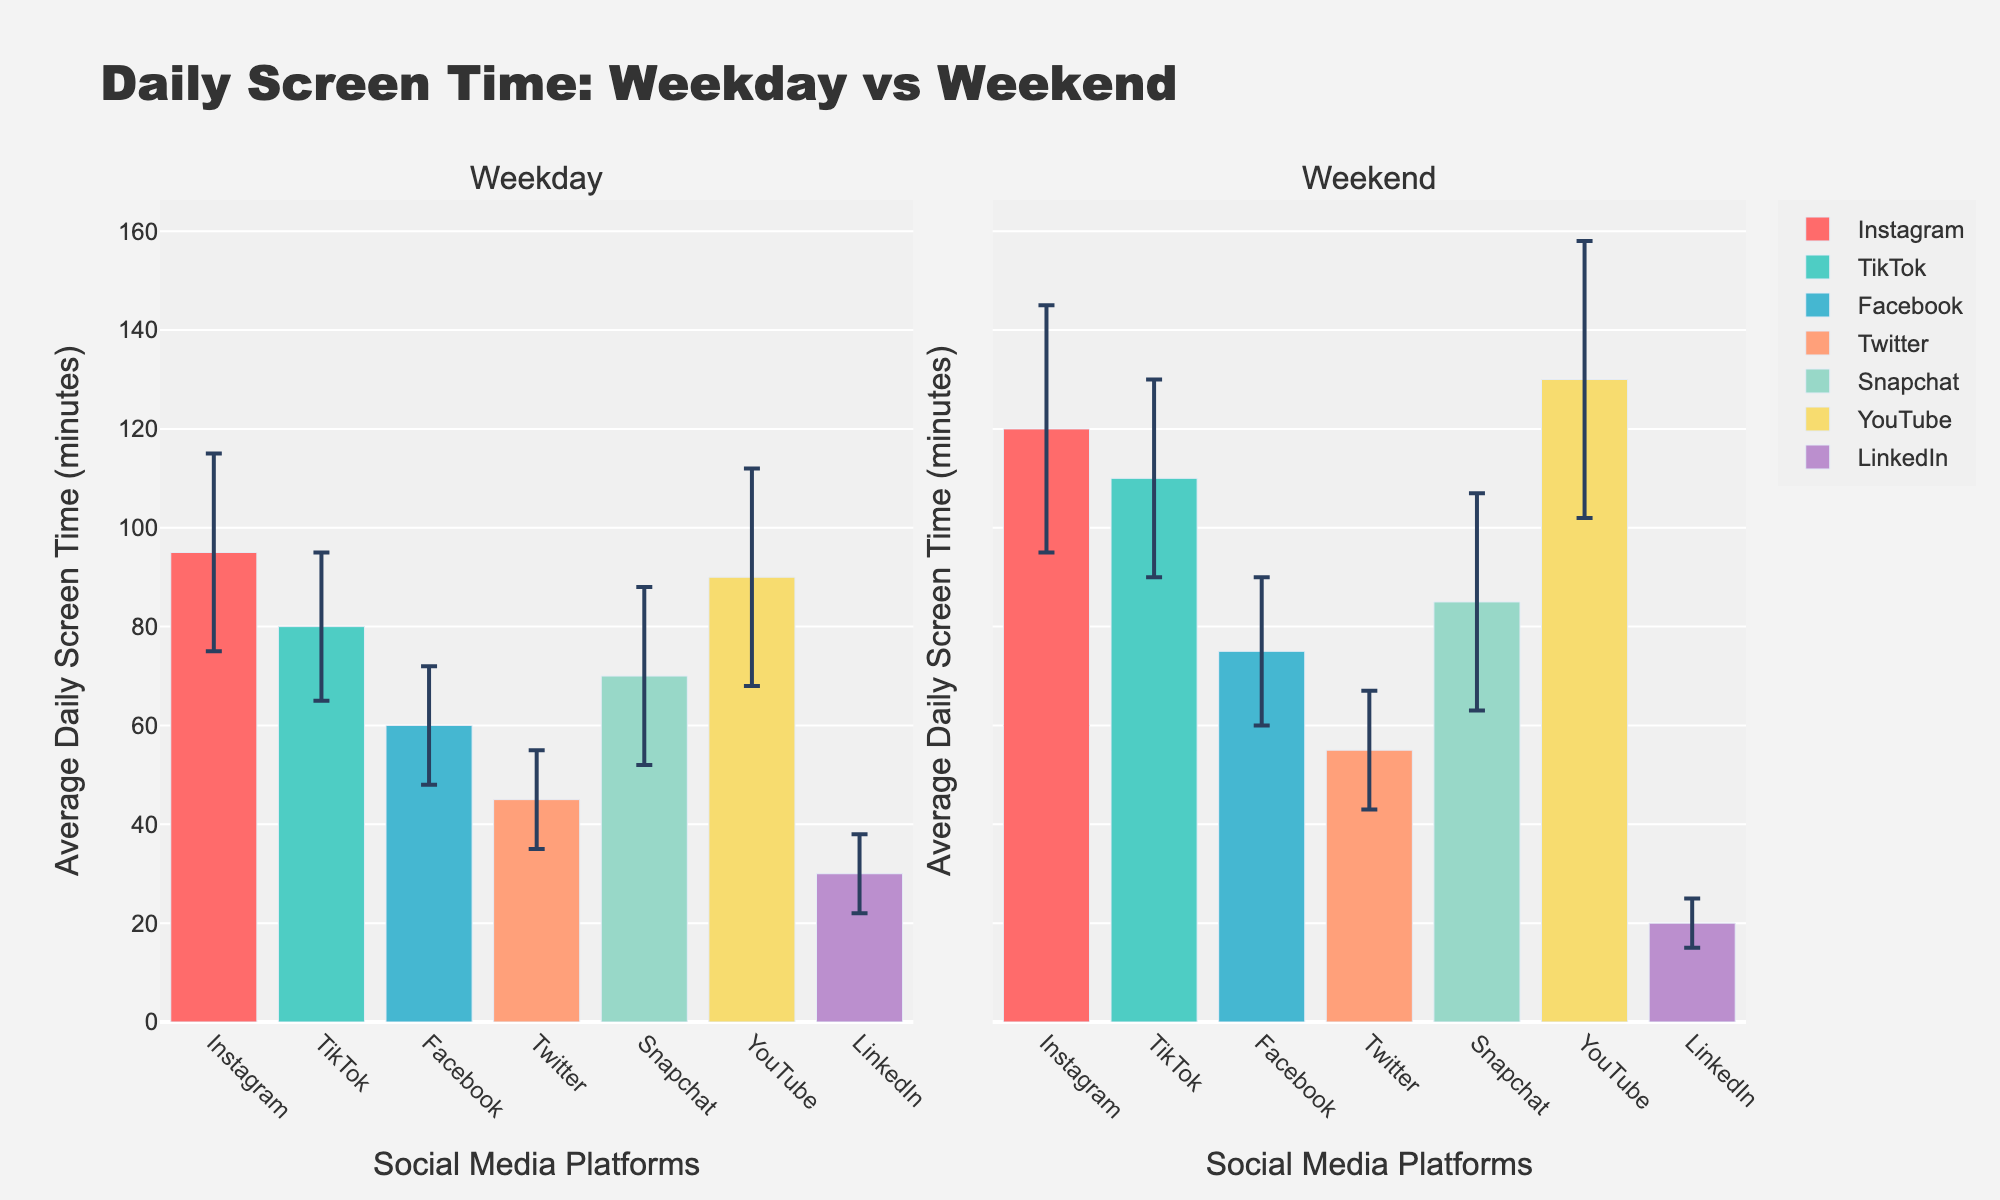What does the title of the plot say? The title of the plot is found at the very top and serves to explain what the data is about. It reads "Daily Screen Time: Weekday vs Weekend." This title informs the viewer that the plot compares daily screen times across different social media platforms for weekdays and weekends.
Answer: Daily Screen Time: Weekday vs Weekend Which social media platform has the highest average daily screen time on weekends? To find which platform has the highest screen time on weekends, look at the tallest bar in the weekend subplot. YouTube has the tallest bar indicating it has the highest average daily screen time on weekends.
Answer: YouTube How does the average daily screen time for Instagram differ between weekdays and weekends? Compare the height of the bars for Instagram in both the weekday and weekend subplots. The average daily screen time for Instagram is 95 minutes on weekdays and 120 minutes on weekends. The difference is 120 - 95 = 25 minutes.
Answer: 25 minutes Which platform has the smallest increase in screen time from weekday to weekend, and what is the increase? Find the platform with the smallest difference between its weekday and weekend bars. LinkedIn has a screen time decrease from 30 minutes on weekdays to 20 minutes on weekends, which is actually a decrease of 10 minutes. While others have increases, LinkedIn displays a different behavior.
Answer: LinkedIn, -10 minutes What is the average daily screen time on weekdays for Twitter? Look at the height of the bar for Twitter in the weekday subplot. The bar indicates that the average daily screen time is 45 minutes.
Answer: 45 minutes Which platform has the largest error bar on weekdays and how large is it? The error bars indicate the variability in data. The largest error bar for weekdays belongs to YouTube, which has a standard deviation of 22 minutes on weekdays.
Answer: YouTube, 22 minutes Compare the error bar sizes for Snapchat on weekdays and weekends. Which one is larger and by how much? To compare, look at the error bars for Snapchat in both subplots. The weekend error bar is 22 minutes, and the weekday error bar is 18 minutes. The difference is 22 - 18 = 4 minutes.
Answer: Weekend error bar larger by 4 minutes How much more time is spent on TikTok during weekends compared to weekdays? Compare the heights of the bars for TikTok in both subplots. The average daily screen time is 80 minutes on weekdays and 110 minutes on weekends, thus 110 - 80 = 30 minutes more on weekends.
Answer: 30 minutes What is the total average daily screen time for all platforms on weekends? Sum the average daily screen times for all platforms on weekends: 120 (Instagram) + 110 (TikTok) + 75 (Facebook) + 55 (Twitter) + 85 (Snapchat) + 130 (YouTube) + 20 (LinkedIn) = 595 minutes.
Answer: 595 minutes 